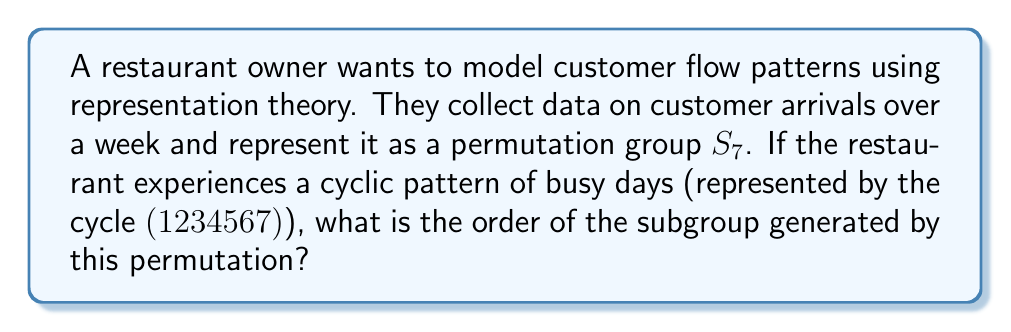Could you help me with this problem? Let's approach this step-by-step:

1) In representation theory, we can model the customer flow pattern as a permutation in the symmetric group $S_7$, where each number represents a day of the week.

2) The given cycle $(1234567)$ represents a cyclic pattern of busy days throughout the week.

3) To find the order of the subgroup generated by this permutation, we need to determine the smallest positive integer $n$ such that $$(1234567)^n = e$$
   where $e$ is the identity permutation.

4) In cyclic notation, $(1234567)^2 = (1357246)$, $(1234567)^3 = (1526374)$, and so on.

5) We can see that we need to apply the permutation 7 times to get back to the identity:
   $$(1234567)^7 = (1)(2)(3)(4)(5)(6)(7) = e$$

6) Therefore, the order of the subgroup generated by this permutation is 7.

This means that the busy day pattern repeats every 7 days, which coincides with the natural weekly cycle.
Answer: 7 